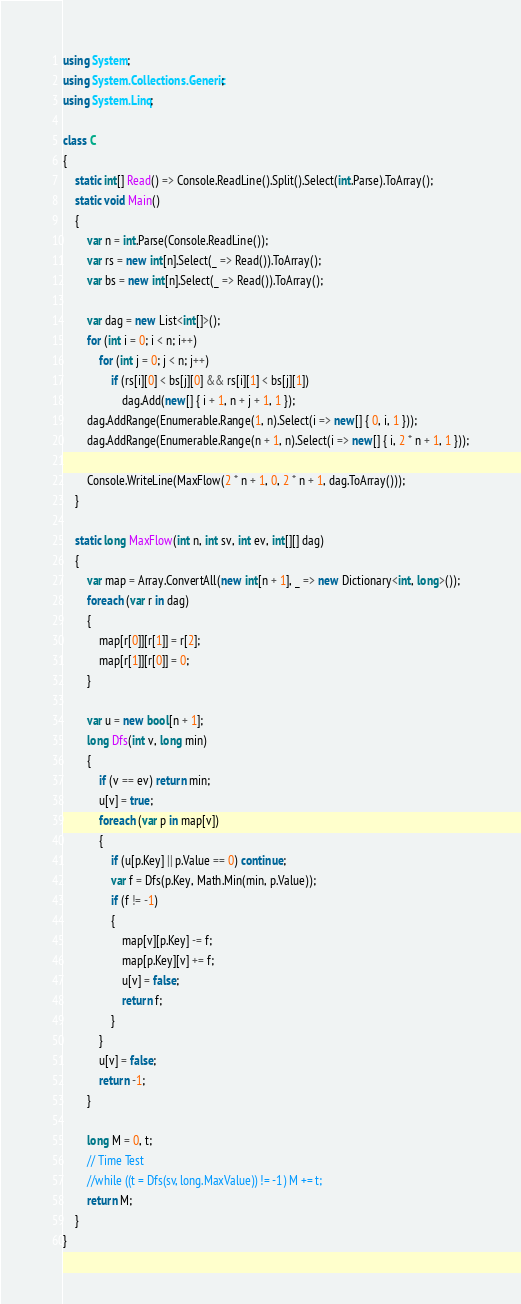<code> <loc_0><loc_0><loc_500><loc_500><_C#_>using System;
using System.Collections.Generic;
using System.Linq;

class C
{
	static int[] Read() => Console.ReadLine().Split().Select(int.Parse).ToArray();
	static void Main()
	{
		var n = int.Parse(Console.ReadLine());
		var rs = new int[n].Select(_ => Read()).ToArray();
		var bs = new int[n].Select(_ => Read()).ToArray();

		var dag = new List<int[]>();
		for (int i = 0; i < n; i++)
			for (int j = 0; j < n; j++)
				if (rs[i][0] < bs[j][0] && rs[i][1] < bs[j][1])
					dag.Add(new[] { i + 1, n + j + 1, 1 });
		dag.AddRange(Enumerable.Range(1, n).Select(i => new[] { 0, i, 1 }));
		dag.AddRange(Enumerable.Range(n + 1, n).Select(i => new[] { i, 2 * n + 1, 1 }));

		Console.WriteLine(MaxFlow(2 * n + 1, 0, 2 * n + 1, dag.ToArray()));
	}

	static long MaxFlow(int n, int sv, int ev, int[][] dag)
	{
		var map = Array.ConvertAll(new int[n + 1], _ => new Dictionary<int, long>());
		foreach (var r in dag)
		{
			map[r[0]][r[1]] = r[2];
			map[r[1]][r[0]] = 0;
		}

		var u = new bool[n + 1];
		long Dfs(int v, long min)
		{
			if (v == ev) return min;
			u[v] = true;
			foreach (var p in map[v])
			{
				if (u[p.Key] || p.Value == 0) continue;
				var f = Dfs(p.Key, Math.Min(min, p.Value));
				if (f != -1)
				{
					map[v][p.Key] -= f;
					map[p.Key][v] += f;
					u[v] = false;
					return f;
				}
			}
			u[v] = false;
			return -1;
		}

		long M = 0, t;
		// Time Test
		//while ((t = Dfs(sv, long.MaxValue)) != -1) M += t;
		return M;
	}
}
</code> 